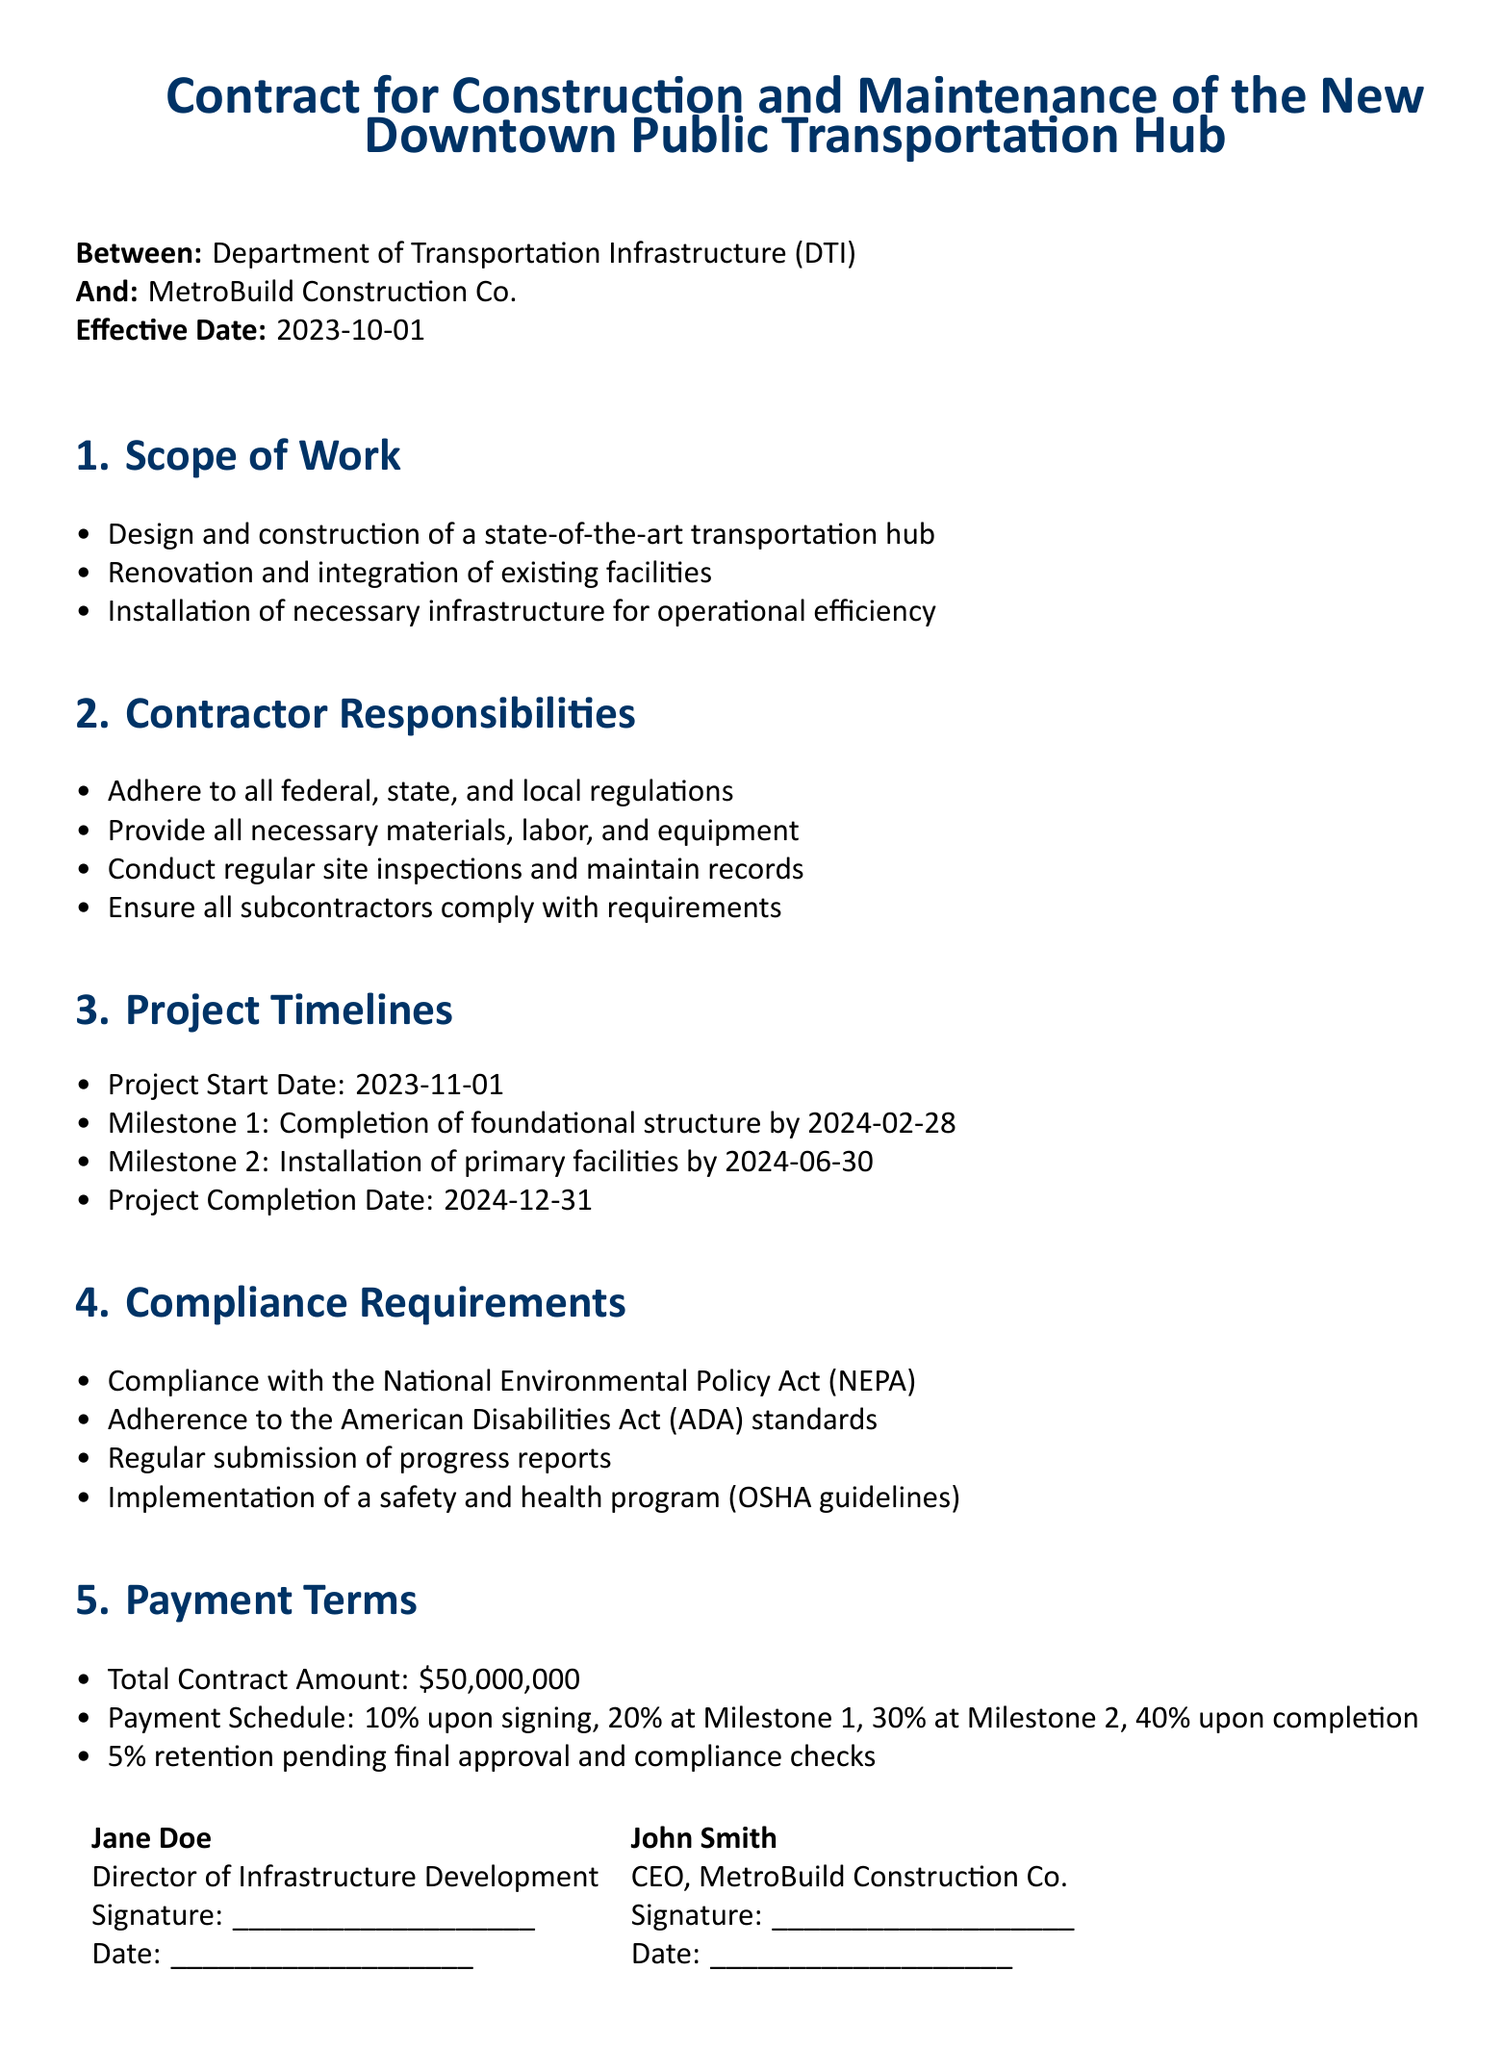What is the effective date of the contract? The effective date is explicitly stated in the document.
Answer: 2023-10-01 Who is the contractor for the project? The contractor's name is listed at the beginning of the document under "And".
Answer: MetroBuild Construction Co When is the project start date? The start date is clearly indicated in the project timelines section.
Answer: 2023-11-01 What is the total contract amount? The total amount is stated in the payment terms section.
Answer: $50,000,000 What is Milestone 1's completion date? This date is specified under the project timelines section as Milestone 1.
Answer: 2024-02-28 Which act must the contractor comply with? The compliance requirements section outlines specific acts and standards.
Answer: National Environmental Policy Act (NEPA) How much is the payment upon signing? The payment terms detail the schedule of payments, including the percentage due upon signing.
Answer: 10% What is the final completion date of the project? The project completion date is stated in the project timelines section.
Answer: 2024-12-31 What safety guidelines must be implemented? The compliance requirements include the need for adherence to specific safety guidelines.
Answer: OSHA guidelines 